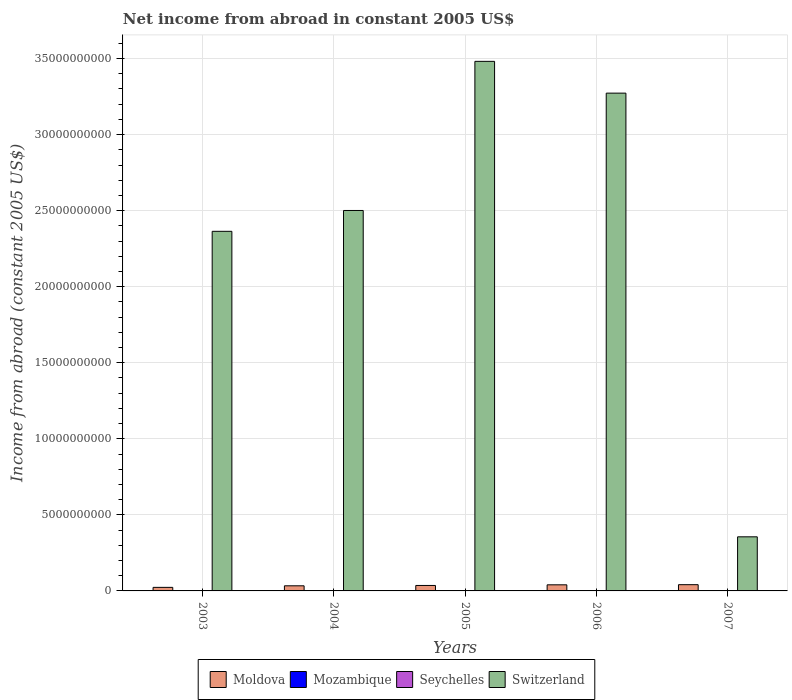How many groups of bars are there?
Make the answer very short. 5. Are the number of bars per tick equal to the number of legend labels?
Offer a terse response. No. Are the number of bars on each tick of the X-axis equal?
Ensure brevity in your answer.  No. How many bars are there on the 3rd tick from the left?
Provide a succinct answer. 3. How many bars are there on the 5th tick from the right?
Give a very brief answer. 2. In how many cases, is the number of bars for a given year not equal to the number of legend labels?
Ensure brevity in your answer.  5. What is the net income from abroad in Switzerland in 2005?
Offer a very short reply. 3.48e+1. Across all years, what is the maximum net income from abroad in Seychelles?
Make the answer very short. 1.04e+07. Across all years, what is the minimum net income from abroad in Moldova?
Ensure brevity in your answer.  2.34e+08. What is the difference between the net income from abroad in Moldova in 2004 and that in 2005?
Keep it short and to the point. -2.23e+07. What is the difference between the net income from abroad in Seychelles in 2007 and the net income from abroad in Moldova in 2003?
Your answer should be compact. -2.34e+08. What is the average net income from abroad in Seychelles per year?
Keep it short and to the point. 5.92e+06. In the year 2006, what is the difference between the net income from abroad in Switzerland and net income from abroad in Seychelles?
Make the answer very short. 3.27e+1. What is the ratio of the net income from abroad in Seychelles in 2004 to that in 2006?
Give a very brief answer. 0.91. Is the net income from abroad in Switzerland in 2004 less than that in 2005?
Offer a very short reply. Yes. Is the difference between the net income from abroad in Switzerland in 2004 and 2006 greater than the difference between the net income from abroad in Seychelles in 2004 and 2006?
Make the answer very short. No. What is the difference between the highest and the second highest net income from abroad in Switzerland?
Offer a terse response. 2.09e+09. What is the difference between the highest and the lowest net income from abroad in Moldova?
Your answer should be compact. 1.76e+08. Is it the case that in every year, the sum of the net income from abroad in Mozambique and net income from abroad in Moldova is greater than the net income from abroad in Switzerland?
Ensure brevity in your answer.  No. Are the values on the major ticks of Y-axis written in scientific E-notation?
Make the answer very short. No. Does the graph contain any zero values?
Your answer should be compact. Yes. Does the graph contain grids?
Offer a very short reply. Yes. How many legend labels are there?
Ensure brevity in your answer.  4. How are the legend labels stacked?
Make the answer very short. Horizontal. What is the title of the graph?
Provide a short and direct response. Net income from abroad in constant 2005 US$. Does "Mauritius" appear as one of the legend labels in the graph?
Offer a very short reply. No. What is the label or title of the X-axis?
Your answer should be very brief. Years. What is the label or title of the Y-axis?
Give a very brief answer. Income from abroad (constant 2005 US$). What is the Income from abroad (constant 2005 US$) in Moldova in 2003?
Offer a terse response. 2.34e+08. What is the Income from abroad (constant 2005 US$) in Mozambique in 2003?
Your response must be concise. 0. What is the Income from abroad (constant 2005 US$) in Switzerland in 2003?
Provide a succinct answer. 2.36e+1. What is the Income from abroad (constant 2005 US$) of Moldova in 2004?
Your answer should be compact. 3.37e+08. What is the Income from abroad (constant 2005 US$) of Seychelles in 2004?
Your response must be concise. 9.44e+06. What is the Income from abroad (constant 2005 US$) in Switzerland in 2004?
Give a very brief answer. 2.50e+1. What is the Income from abroad (constant 2005 US$) of Moldova in 2005?
Your answer should be very brief. 3.59e+08. What is the Income from abroad (constant 2005 US$) in Seychelles in 2005?
Your answer should be very brief. 9.81e+06. What is the Income from abroad (constant 2005 US$) of Switzerland in 2005?
Ensure brevity in your answer.  3.48e+1. What is the Income from abroad (constant 2005 US$) of Moldova in 2006?
Ensure brevity in your answer.  4.01e+08. What is the Income from abroad (constant 2005 US$) in Seychelles in 2006?
Offer a very short reply. 1.04e+07. What is the Income from abroad (constant 2005 US$) of Switzerland in 2006?
Make the answer very short. 3.27e+1. What is the Income from abroad (constant 2005 US$) of Moldova in 2007?
Make the answer very short. 4.10e+08. What is the Income from abroad (constant 2005 US$) of Seychelles in 2007?
Offer a terse response. 0. What is the Income from abroad (constant 2005 US$) in Switzerland in 2007?
Your response must be concise. 3.56e+09. Across all years, what is the maximum Income from abroad (constant 2005 US$) in Moldova?
Offer a very short reply. 4.10e+08. Across all years, what is the maximum Income from abroad (constant 2005 US$) in Seychelles?
Your answer should be compact. 1.04e+07. Across all years, what is the maximum Income from abroad (constant 2005 US$) of Switzerland?
Your response must be concise. 3.48e+1. Across all years, what is the minimum Income from abroad (constant 2005 US$) in Moldova?
Provide a short and direct response. 2.34e+08. Across all years, what is the minimum Income from abroad (constant 2005 US$) of Switzerland?
Your response must be concise. 3.56e+09. What is the total Income from abroad (constant 2005 US$) in Moldova in the graph?
Offer a terse response. 1.74e+09. What is the total Income from abroad (constant 2005 US$) of Seychelles in the graph?
Your response must be concise. 2.96e+07. What is the total Income from abroad (constant 2005 US$) in Switzerland in the graph?
Provide a short and direct response. 1.20e+11. What is the difference between the Income from abroad (constant 2005 US$) in Moldova in 2003 and that in 2004?
Offer a terse response. -1.02e+08. What is the difference between the Income from abroad (constant 2005 US$) in Switzerland in 2003 and that in 2004?
Keep it short and to the point. -1.37e+09. What is the difference between the Income from abroad (constant 2005 US$) of Moldova in 2003 and that in 2005?
Provide a succinct answer. -1.25e+08. What is the difference between the Income from abroad (constant 2005 US$) of Switzerland in 2003 and that in 2005?
Offer a very short reply. -1.12e+1. What is the difference between the Income from abroad (constant 2005 US$) in Moldova in 2003 and that in 2006?
Your answer should be very brief. -1.67e+08. What is the difference between the Income from abroad (constant 2005 US$) in Switzerland in 2003 and that in 2006?
Provide a short and direct response. -9.09e+09. What is the difference between the Income from abroad (constant 2005 US$) in Moldova in 2003 and that in 2007?
Keep it short and to the point. -1.76e+08. What is the difference between the Income from abroad (constant 2005 US$) in Switzerland in 2003 and that in 2007?
Your answer should be compact. 2.01e+1. What is the difference between the Income from abroad (constant 2005 US$) of Moldova in 2004 and that in 2005?
Give a very brief answer. -2.23e+07. What is the difference between the Income from abroad (constant 2005 US$) in Seychelles in 2004 and that in 2005?
Provide a succinct answer. -3.71e+05. What is the difference between the Income from abroad (constant 2005 US$) in Switzerland in 2004 and that in 2005?
Your answer should be very brief. -9.80e+09. What is the difference between the Income from abroad (constant 2005 US$) of Moldova in 2004 and that in 2006?
Provide a succinct answer. -6.49e+07. What is the difference between the Income from abroad (constant 2005 US$) of Seychelles in 2004 and that in 2006?
Offer a very short reply. -9.14e+05. What is the difference between the Income from abroad (constant 2005 US$) of Switzerland in 2004 and that in 2006?
Give a very brief answer. -7.71e+09. What is the difference between the Income from abroad (constant 2005 US$) of Moldova in 2004 and that in 2007?
Your answer should be very brief. -7.37e+07. What is the difference between the Income from abroad (constant 2005 US$) in Switzerland in 2004 and that in 2007?
Provide a short and direct response. 2.15e+1. What is the difference between the Income from abroad (constant 2005 US$) of Moldova in 2005 and that in 2006?
Ensure brevity in your answer.  -4.26e+07. What is the difference between the Income from abroad (constant 2005 US$) of Seychelles in 2005 and that in 2006?
Your answer should be compact. -5.42e+05. What is the difference between the Income from abroad (constant 2005 US$) in Switzerland in 2005 and that in 2006?
Your answer should be compact. 2.09e+09. What is the difference between the Income from abroad (constant 2005 US$) in Moldova in 2005 and that in 2007?
Your response must be concise. -5.14e+07. What is the difference between the Income from abroad (constant 2005 US$) of Switzerland in 2005 and that in 2007?
Offer a terse response. 3.13e+1. What is the difference between the Income from abroad (constant 2005 US$) in Moldova in 2006 and that in 2007?
Keep it short and to the point. -8.77e+06. What is the difference between the Income from abroad (constant 2005 US$) of Switzerland in 2006 and that in 2007?
Keep it short and to the point. 2.92e+1. What is the difference between the Income from abroad (constant 2005 US$) of Moldova in 2003 and the Income from abroad (constant 2005 US$) of Seychelles in 2004?
Your answer should be compact. 2.25e+08. What is the difference between the Income from abroad (constant 2005 US$) of Moldova in 2003 and the Income from abroad (constant 2005 US$) of Switzerland in 2004?
Ensure brevity in your answer.  -2.48e+1. What is the difference between the Income from abroad (constant 2005 US$) of Moldova in 2003 and the Income from abroad (constant 2005 US$) of Seychelles in 2005?
Make the answer very short. 2.24e+08. What is the difference between the Income from abroad (constant 2005 US$) in Moldova in 2003 and the Income from abroad (constant 2005 US$) in Switzerland in 2005?
Give a very brief answer. -3.46e+1. What is the difference between the Income from abroad (constant 2005 US$) in Moldova in 2003 and the Income from abroad (constant 2005 US$) in Seychelles in 2006?
Provide a succinct answer. 2.24e+08. What is the difference between the Income from abroad (constant 2005 US$) of Moldova in 2003 and the Income from abroad (constant 2005 US$) of Switzerland in 2006?
Your response must be concise. -3.25e+1. What is the difference between the Income from abroad (constant 2005 US$) of Moldova in 2003 and the Income from abroad (constant 2005 US$) of Switzerland in 2007?
Provide a short and direct response. -3.32e+09. What is the difference between the Income from abroad (constant 2005 US$) of Moldova in 2004 and the Income from abroad (constant 2005 US$) of Seychelles in 2005?
Your answer should be very brief. 3.27e+08. What is the difference between the Income from abroad (constant 2005 US$) of Moldova in 2004 and the Income from abroad (constant 2005 US$) of Switzerland in 2005?
Offer a very short reply. -3.45e+1. What is the difference between the Income from abroad (constant 2005 US$) in Seychelles in 2004 and the Income from abroad (constant 2005 US$) in Switzerland in 2005?
Your answer should be very brief. -3.48e+1. What is the difference between the Income from abroad (constant 2005 US$) in Moldova in 2004 and the Income from abroad (constant 2005 US$) in Seychelles in 2006?
Your answer should be compact. 3.26e+08. What is the difference between the Income from abroad (constant 2005 US$) of Moldova in 2004 and the Income from abroad (constant 2005 US$) of Switzerland in 2006?
Ensure brevity in your answer.  -3.24e+1. What is the difference between the Income from abroad (constant 2005 US$) in Seychelles in 2004 and the Income from abroad (constant 2005 US$) in Switzerland in 2006?
Ensure brevity in your answer.  -3.27e+1. What is the difference between the Income from abroad (constant 2005 US$) of Moldova in 2004 and the Income from abroad (constant 2005 US$) of Switzerland in 2007?
Provide a short and direct response. -3.22e+09. What is the difference between the Income from abroad (constant 2005 US$) of Seychelles in 2004 and the Income from abroad (constant 2005 US$) of Switzerland in 2007?
Keep it short and to the point. -3.55e+09. What is the difference between the Income from abroad (constant 2005 US$) in Moldova in 2005 and the Income from abroad (constant 2005 US$) in Seychelles in 2006?
Your response must be concise. 3.48e+08. What is the difference between the Income from abroad (constant 2005 US$) in Moldova in 2005 and the Income from abroad (constant 2005 US$) in Switzerland in 2006?
Provide a succinct answer. -3.24e+1. What is the difference between the Income from abroad (constant 2005 US$) of Seychelles in 2005 and the Income from abroad (constant 2005 US$) of Switzerland in 2006?
Make the answer very short. -3.27e+1. What is the difference between the Income from abroad (constant 2005 US$) of Moldova in 2005 and the Income from abroad (constant 2005 US$) of Switzerland in 2007?
Keep it short and to the point. -3.20e+09. What is the difference between the Income from abroad (constant 2005 US$) of Seychelles in 2005 and the Income from abroad (constant 2005 US$) of Switzerland in 2007?
Your answer should be very brief. -3.55e+09. What is the difference between the Income from abroad (constant 2005 US$) in Moldova in 2006 and the Income from abroad (constant 2005 US$) in Switzerland in 2007?
Provide a succinct answer. -3.16e+09. What is the difference between the Income from abroad (constant 2005 US$) of Seychelles in 2006 and the Income from abroad (constant 2005 US$) of Switzerland in 2007?
Your answer should be very brief. -3.55e+09. What is the average Income from abroad (constant 2005 US$) of Moldova per year?
Offer a terse response. 3.48e+08. What is the average Income from abroad (constant 2005 US$) of Seychelles per year?
Offer a terse response. 5.92e+06. What is the average Income from abroad (constant 2005 US$) of Switzerland per year?
Make the answer very short. 2.40e+1. In the year 2003, what is the difference between the Income from abroad (constant 2005 US$) in Moldova and Income from abroad (constant 2005 US$) in Switzerland?
Make the answer very short. -2.34e+1. In the year 2004, what is the difference between the Income from abroad (constant 2005 US$) in Moldova and Income from abroad (constant 2005 US$) in Seychelles?
Make the answer very short. 3.27e+08. In the year 2004, what is the difference between the Income from abroad (constant 2005 US$) of Moldova and Income from abroad (constant 2005 US$) of Switzerland?
Make the answer very short. -2.47e+1. In the year 2004, what is the difference between the Income from abroad (constant 2005 US$) in Seychelles and Income from abroad (constant 2005 US$) in Switzerland?
Provide a short and direct response. -2.50e+1. In the year 2005, what is the difference between the Income from abroad (constant 2005 US$) of Moldova and Income from abroad (constant 2005 US$) of Seychelles?
Your response must be concise. 3.49e+08. In the year 2005, what is the difference between the Income from abroad (constant 2005 US$) in Moldova and Income from abroad (constant 2005 US$) in Switzerland?
Provide a succinct answer. -3.45e+1. In the year 2005, what is the difference between the Income from abroad (constant 2005 US$) in Seychelles and Income from abroad (constant 2005 US$) in Switzerland?
Give a very brief answer. -3.48e+1. In the year 2006, what is the difference between the Income from abroad (constant 2005 US$) in Moldova and Income from abroad (constant 2005 US$) in Seychelles?
Keep it short and to the point. 3.91e+08. In the year 2006, what is the difference between the Income from abroad (constant 2005 US$) of Moldova and Income from abroad (constant 2005 US$) of Switzerland?
Your answer should be compact. -3.23e+1. In the year 2006, what is the difference between the Income from abroad (constant 2005 US$) of Seychelles and Income from abroad (constant 2005 US$) of Switzerland?
Offer a terse response. -3.27e+1. In the year 2007, what is the difference between the Income from abroad (constant 2005 US$) of Moldova and Income from abroad (constant 2005 US$) of Switzerland?
Make the answer very short. -3.15e+09. What is the ratio of the Income from abroad (constant 2005 US$) of Moldova in 2003 to that in 2004?
Give a very brief answer. 0.7. What is the ratio of the Income from abroad (constant 2005 US$) in Switzerland in 2003 to that in 2004?
Offer a very short reply. 0.95. What is the ratio of the Income from abroad (constant 2005 US$) in Moldova in 2003 to that in 2005?
Keep it short and to the point. 0.65. What is the ratio of the Income from abroad (constant 2005 US$) of Switzerland in 2003 to that in 2005?
Ensure brevity in your answer.  0.68. What is the ratio of the Income from abroad (constant 2005 US$) of Moldova in 2003 to that in 2006?
Provide a short and direct response. 0.58. What is the ratio of the Income from abroad (constant 2005 US$) in Switzerland in 2003 to that in 2006?
Your response must be concise. 0.72. What is the ratio of the Income from abroad (constant 2005 US$) in Moldova in 2003 to that in 2007?
Provide a succinct answer. 0.57. What is the ratio of the Income from abroad (constant 2005 US$) in Switzerland in 2003 to that in 2007?
Your response must be concise. 6.65. What is the ratio of the Income from abroad (constant 2005 US$) in Moldova in 2004 to that in 2005?
Give a very brief answer. 0.94. What is the ratio of the Income from abroad (constant 2005 US$) of Seychelles in 2004 to that in 2005?
Offer a very short reply. 0.96. What is the ratio of the Income from abroad (constant 2005 US$) of Switzerland in 2004 to that in 2005?
Your answer should be compact. 0.72. What is the ratio of the Income from abroad (constant 2005 US$) of Moldova in 2004 to that in 2006?
Your answer should be compact. 0.84. What is the ratio of the Income from abroad (constant 2005 US$) of Seychelles in 2004 to that in 2006?
Your answer should be compact. 0.91. What is the ratio of the Income from abroad (constant 2005 US$) in Switzerland in 2004 to that in 2006?
Your answer should be very brief. 0.76. What is the ratio of the Income from abroad (constant 2005 US$) in Moldova in 2004 to that in 2007?
Your response must be concise. 0.82. What is the ratio of the Income from abroad (constant 2005 US$) in Switzerland in 2004 to that in 2007?
Provide a succinct answer. 7.03. What is the ratio of the Income from abroad (constant 2005 US$) in Moldova in 2005 to that in 2006?
Your answer should be compact. 0.89. What is the ratio of the Income from abroad (constant 2005 US$) in Seychelles in 2005 to that in 2006?
Provide a short and direct response. 0.95. What is the ratio of the Income from abroad (constant 2005 US$) of Switzerland in 2005 to that in 2006?
Offer a terse response. 1.06. What is the ratio of the Income from abroad (constant 2005 US$) of Moldova in 2005 to that in 2007?
Offer a very short reply. 0.87. What is the ratio of the Income from abroad (constant 2005 US$) of Switzerland in 2005 to that in 2007?
Offer a very short reply. 9.79. What is the ratio of the Income from abroad (constant 2005 US$) in Moldova in 2006 to that in 2007?
Make the answer very short. 0.98. What is the ratio of the Income from abroad (constant 2005 US$) of Switzerland in 2006 to that in 2007?
Ensure brevity in your answer.  9.2. What is the difference between the highest and the second highest Income from abroad (constant 2005 US$) of Moldova?
Offer a very short reply. 8.77e+06. What is the difference between the highest and the second highest Income from abroad (constant 2005 US$) in Seychelles?
Offer a terse response. 5.42e+05. What is the difference between the highest and the second highest Income from abroad (constant 2005 US$) of Switzerland?
Offer a terse response. 2.09e+09. What is the difference between the highest and the lowest Income from abroad (constant 2005 US$) in Moldova?
Provide a succinct answer. 1.76e+08. What is the difference between the highest and the lowest Income from abroad (constant 2005 US$) in Seychelles?
Your answer should be very brief. 1.04e+07. What is the difference between the highest and the lowest Income from abroad (constant 2005 US$) of Switzerland?
Your answer should be very brief. 3.13e+1. 